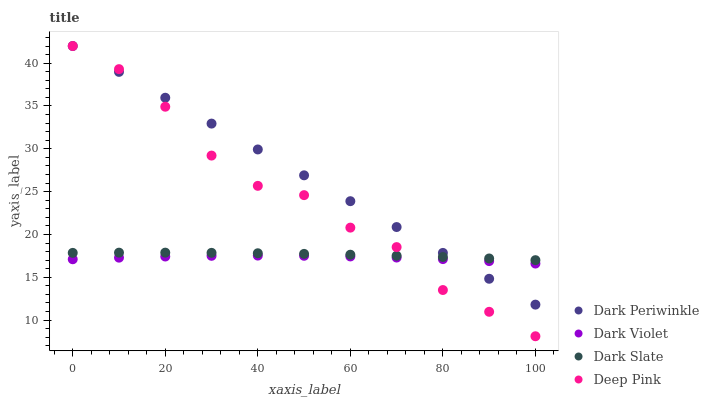Does Dark Violet have the minimum area under the curve?
Answer yes or no. Yes. Does Dark Periwinkle have the maximum area under the curve?
Answer yes or no. Yes. Does Deep Pink have the minimum area under the curve?
Answer yes or no. No. Does Deep Pink have the maximum area under the curve?
Answer yes or no. No. Is Dark Periwinkle the smoothest?
Answer yes or no. Yes. Is Deep Pink the roughest?
Answer yes or no. Yes. Is Deep Pink the smoothest?
Answer yes or no. No. Is Dark Periwinkle the roughest?
Answer yes or no. No. Does Deep Pink have the lowest value?
Answer yes or no. Yes. Does Dark Periwinkle have the lowest value?
Answer yes or no. No. Does Dark Periwinkle have the highest value?
Answer yes or no. Yes. Does Dark Violet have the highest value?
Answer yes or no. No. Is Dark Violet less than Dark Slate?
Answer yes or no. Yes. Is Dark Slate greater than Dark Violet?
Answer yes or no. Yes. Does Deep Pink intersect Dark Periwinkle?
Answer yes or no. Yes. Is Deep Pink less than Dark Periwinkle?
Answer yes or no. No. Is Deep Pink greater than Dark Periwinkle?
Answer yes or no. No. Does Dark Violet intersect Dark Slate?
Answer yes or no. No. 